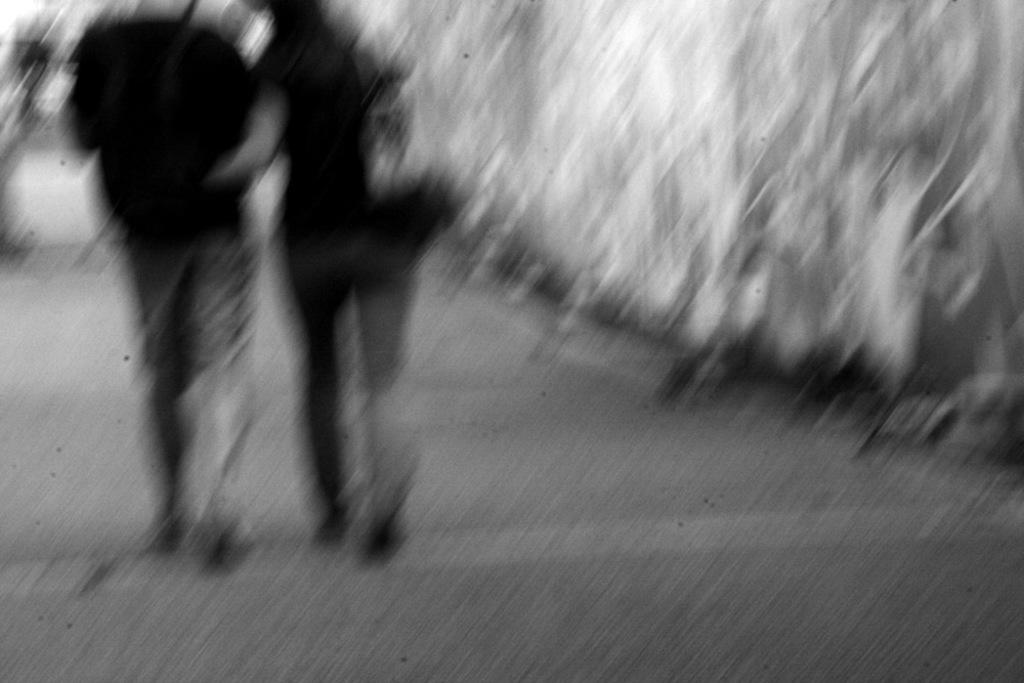What type of picture is in the image? The image contains a black and white picture. How many people are in the picture? There are two persons in the picture. What are the persons doing in the picture? The persons are walking on the ground. What type of card is being held by the woman in the image? There is no woman present in the image, and no card is visible. 